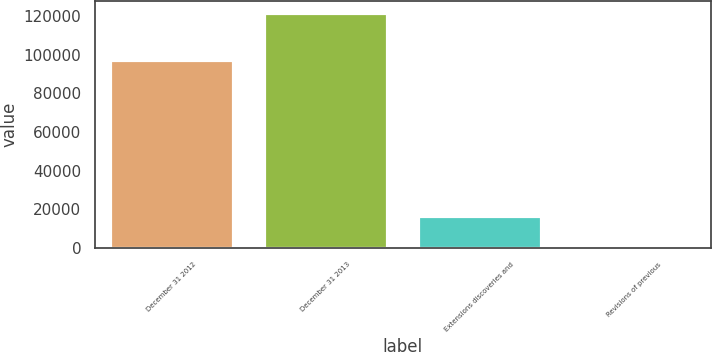Convert chart to OTSL. <chart><loc_0><loc_0><loc_500><loc_500><bar_chart><fcel>December 31 2012<fcel>December 31 2013<fcel>Extensions discoveries and<fcel>Revisions of previous<nl><fcel>97496<fcel>121584<fcel>16515<fcel>49<nl></chart> 